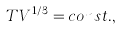<formula> <loc_0><loc_0><loc_500><loc_500>T V ^ { 1 / 3 } = c o n s t . ,</formula> 